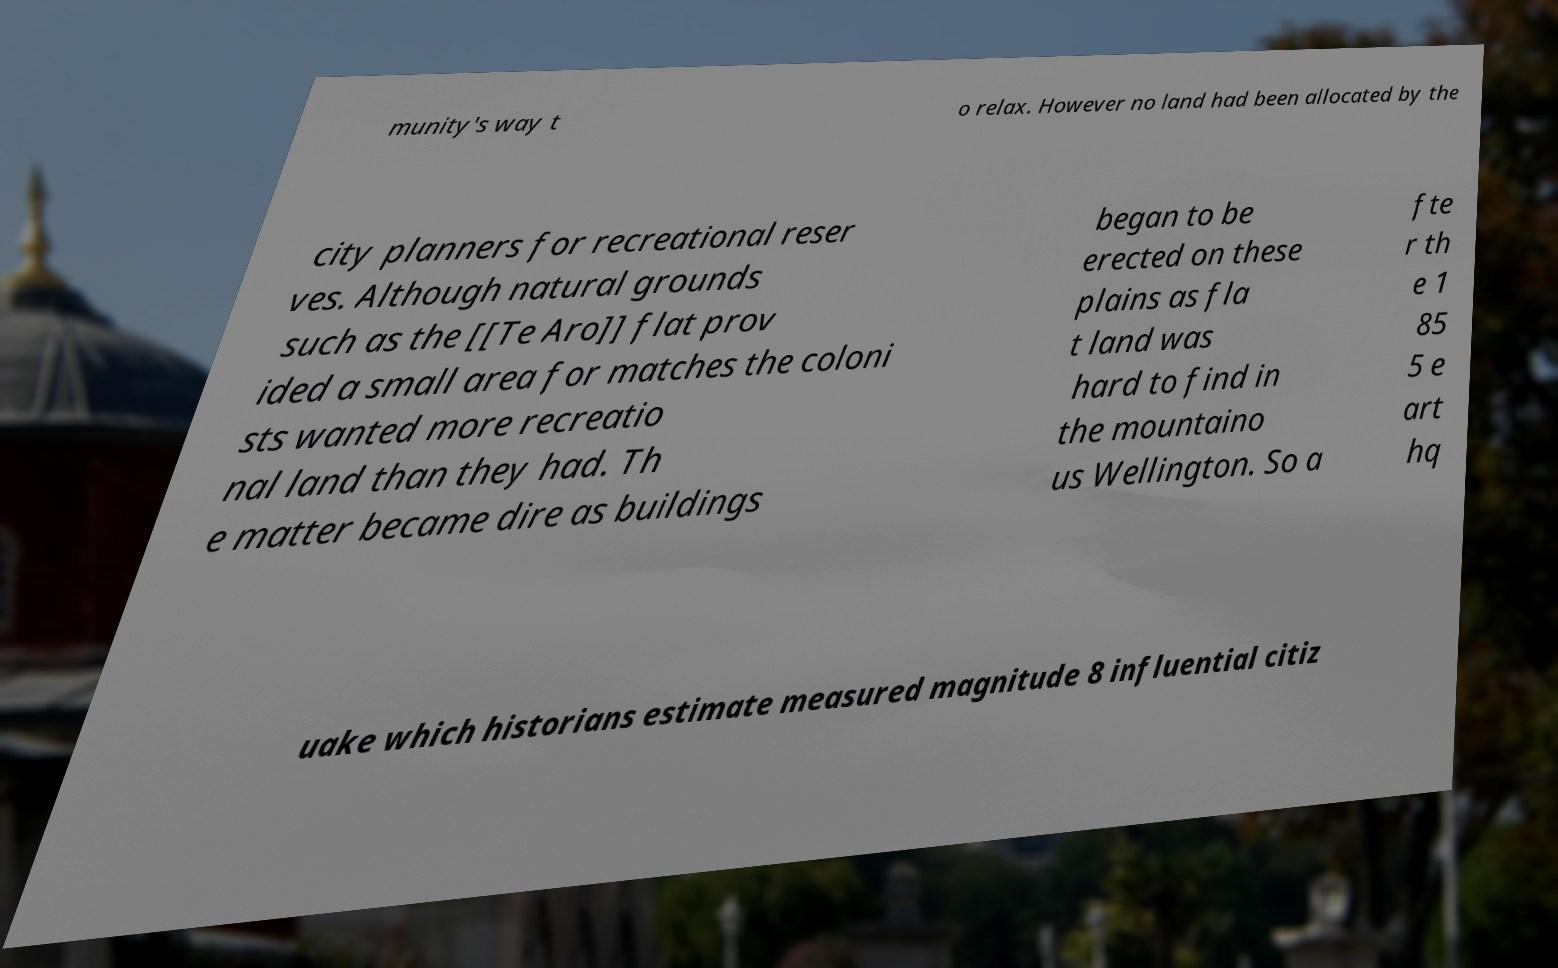What messages or text are displayed in this image? I need them in a readable, typed format. munity's way t o relax. However no land had been allocated by the city planners for recreational reser ves. Although natural grounds such as the [[Te Aro]] flat prov ided a small area for matches the coloni sts wanted more recreatio nal land than they had. Th e matter became dire as buildings began to be erected on these plains as fla t land was hard to find in the mountaino us Wellington. So a fte r th e 1 85 5 e art hq uake which historians estimate measured magnitude 8 influential citiz 